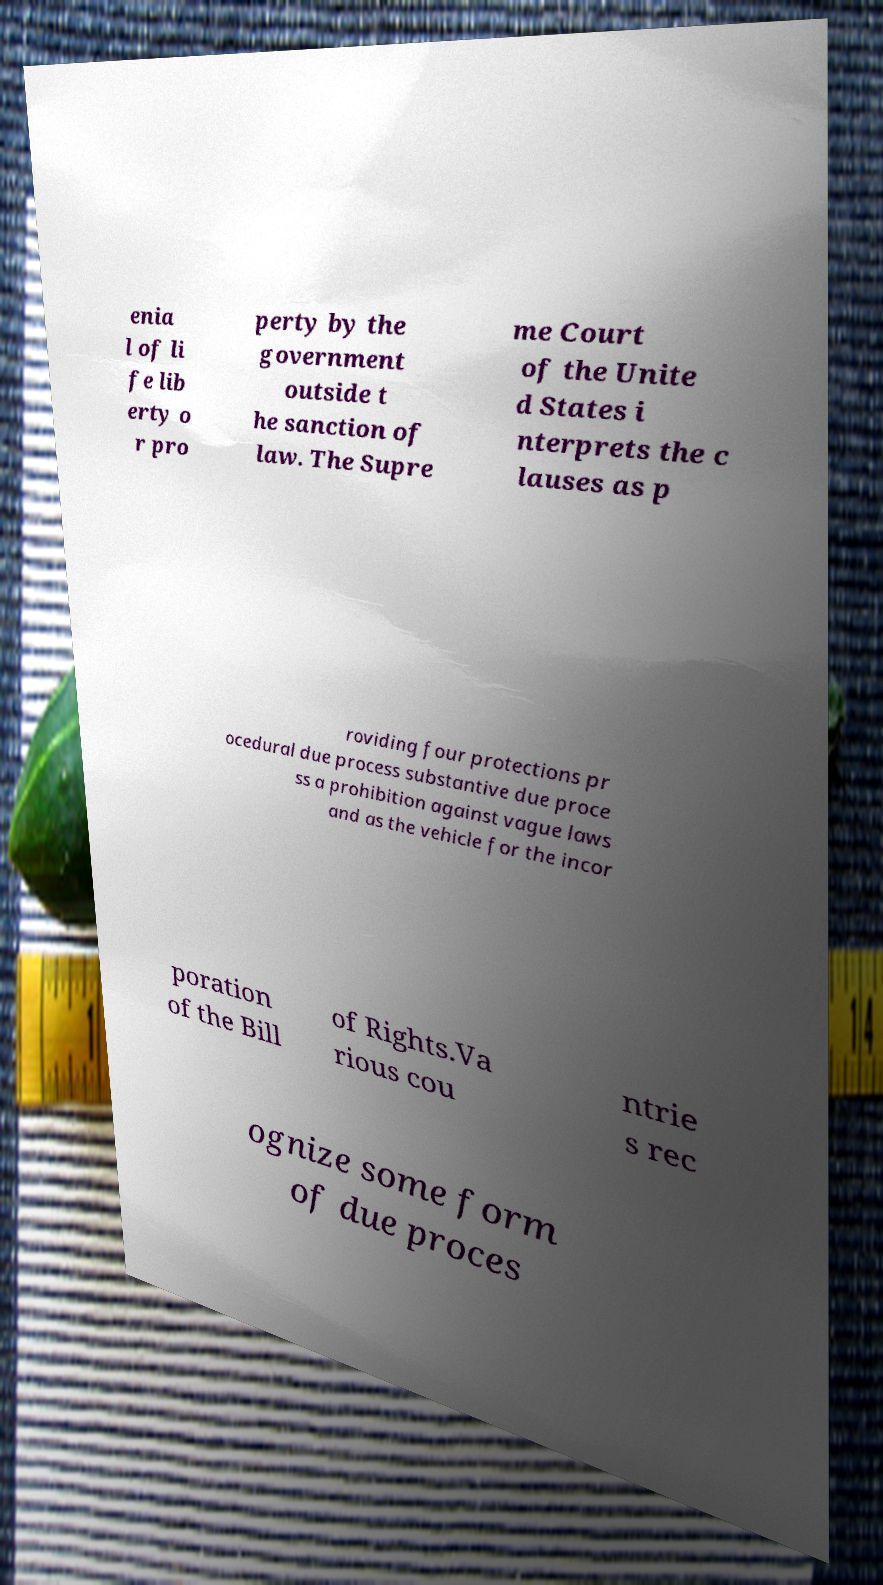I need the written content from this picture converted into text. Can you do that? enia l of li fe lib erty o r pro perty by the government outside t he sanction of law. The Supre me Court of the Unite d States i nterprets the c lauses as p roviding four protections pr ocedural due process substantive due proce ss a prohibition against vague laws and as the vehicle for the incor poration of the Bill of Rights.Va rious cou ntrie s rec ognize some form of due proces 